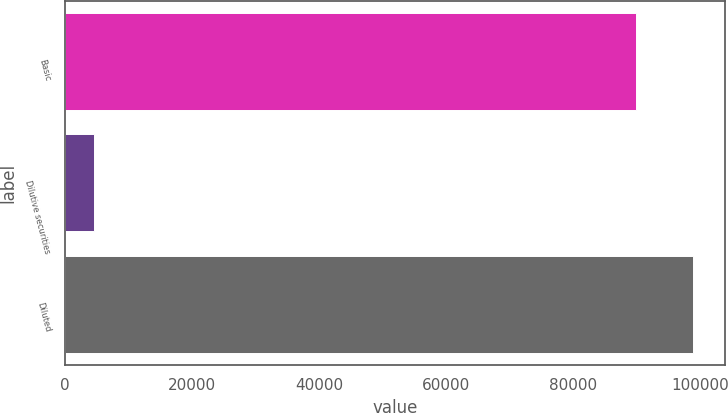Convert chart to OTSL. <chart><loc_0><loc_0><loc_500><loc_500><bar_chart><fcel>Basic<fcel>Dilutive securities<fcel>Diluted<nl><fcel>89967<fcel>4676<fcel>98963.7<nl></chart> 